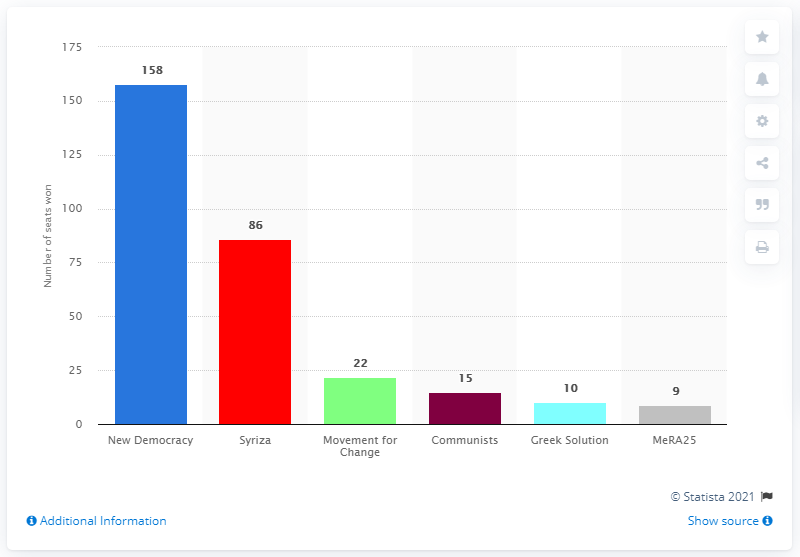Highlight a few significant elements in this photo. The current ruling party in Greece is Syriza. The New Democracy Party won 158 seats in the election. 